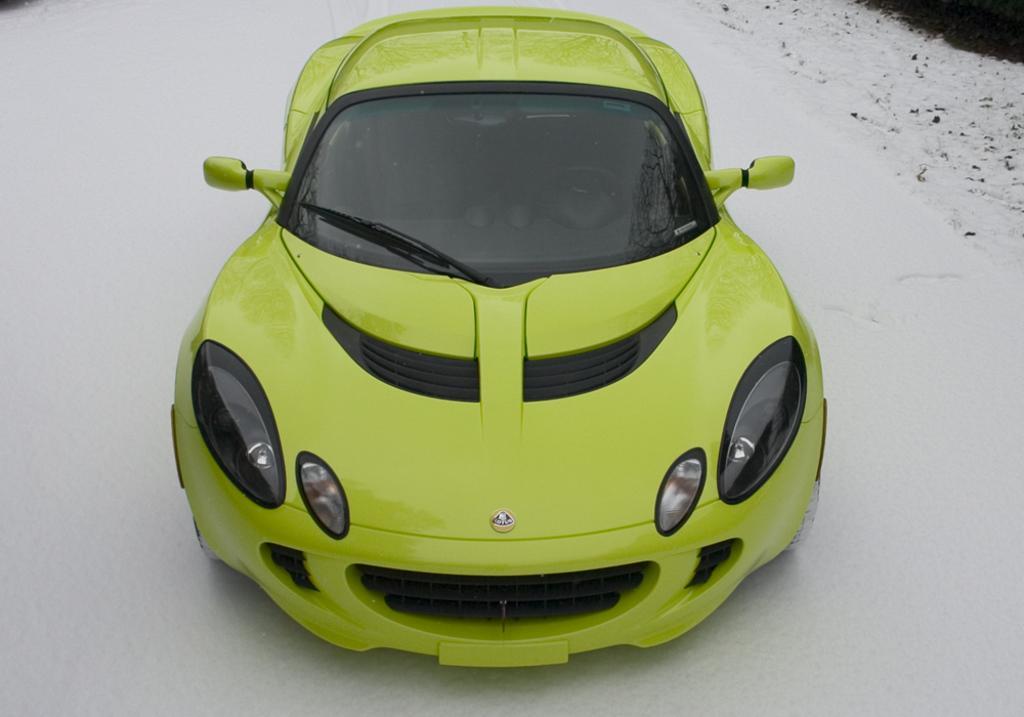How would you summarize this image in a sentence or two? In this image we can see a green colored sports car, which is surrounded by snow. 